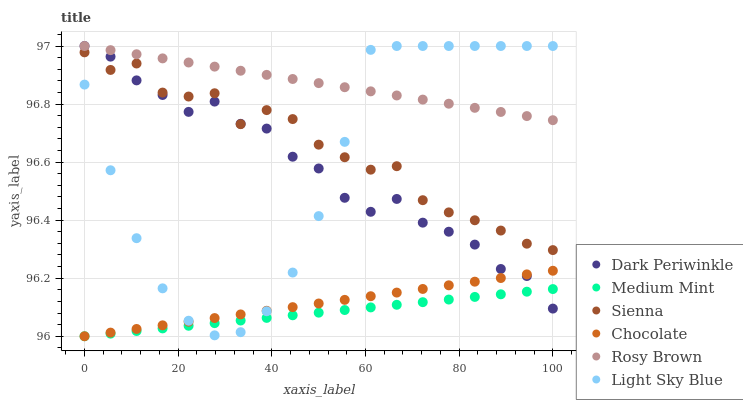Does Medium Mint have the minimum area under the curve?
Answer yes or no. Yes. Does Rosy Brown have the maximum area under the curve?
Answer yes or no. Yes. Does Chocolate have the minimum area under the curve?
Answer yes or no. No. Does Chocolate have the maximum area under the curve?
Answer yes or no. No. Is Chocolate the smoothest?
Answer yes or no. Yes. Is Sienna the roughest?
Answer yes or no. Yes. Is Rosy Brown the smoothest?
Answer yes or no. No. Is Rosy Brown the roughest?
Answer yes or no. No. Does Medium Mint have the lowest value?
Answer yes or no. Yes. Does Rosy Brown have the lowest value?
Answer yes or no. No. Does Dark Periwinkle have the highest value?
Answer yes or no. Yes. Does Chocolate have the highest value?
Answer yes or no. No. Is Chocolate less than Rosy Brown?
Answer yes or no. Yes. Is Rosy Brown greater than Medium Mint?
Answer yes or no. Yes. Does Chocolate intersect Dark Periwinkle?
Answer yes or no. Yes. Is Chocolate less than Dark Periwinkle?
Answer yes or no. No. Is Chocolate greater than Dark Periwinkle?
Answer yes or no. No. Does Chocolate intersect Rosy Brown?
Answer yes or no. No. 